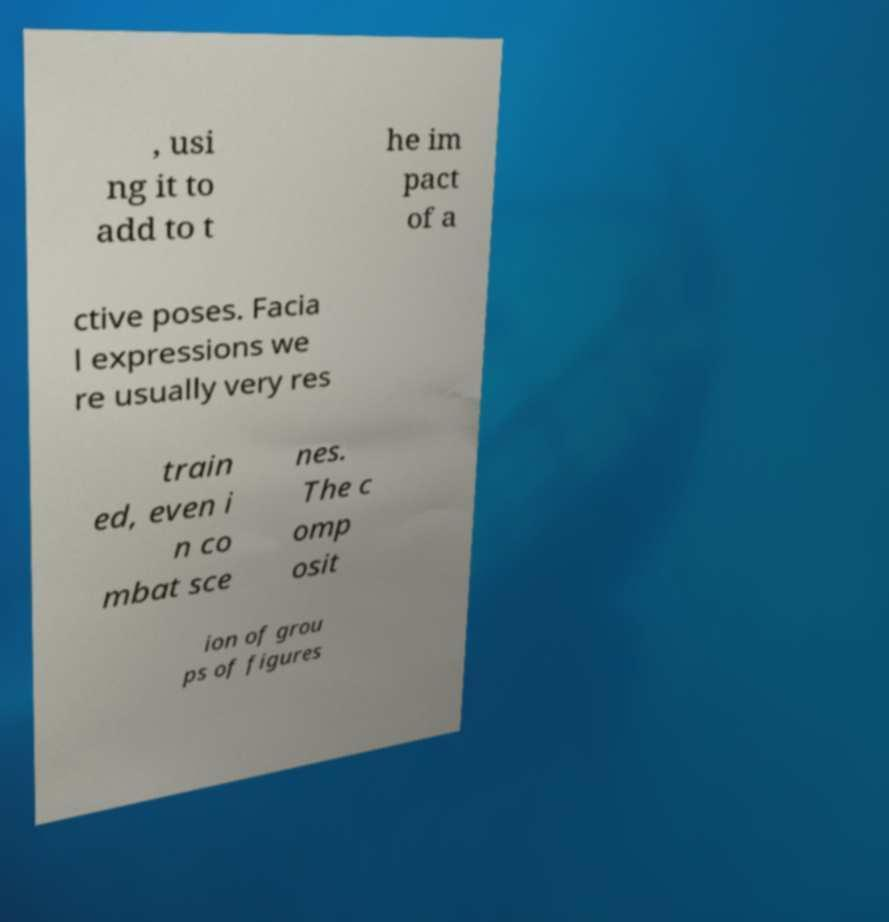Could you assist in decoding the text presented in this image and type it out clearly? , usi ng it to add to t he im pact of a ctive poses. Facia l expressions we re usually very res train ed, even i n co mbat sce nes. The c omp osit ion of grou ps of figures 